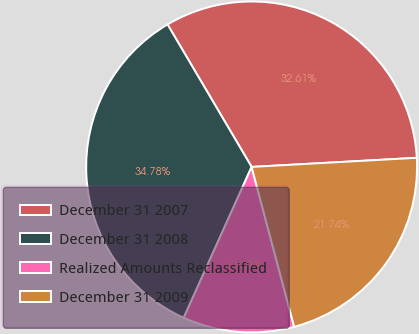<chart> <loc_0><loc_0><loc_500><loc_500><pie_chart><fcel>December 31 2007<fcel>December 31 2008<fcel>Realized Amounts Reclassified<fcel>December 31 2009<nl><fcel>32.61%<fcel>34.78%<fcel>10.87%<fcel>21.74%<nl></chart> 